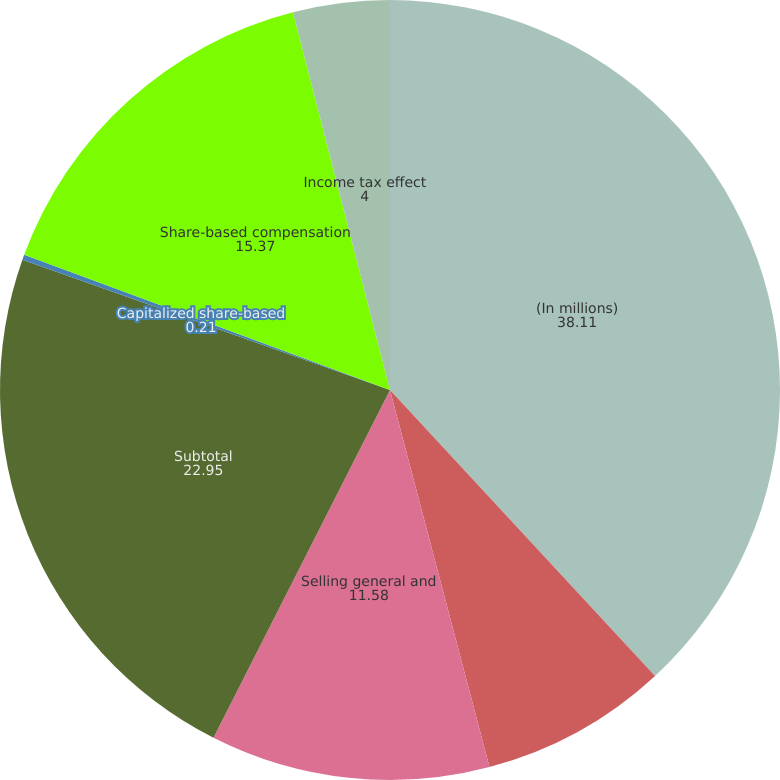<chart> <loc_0><loc_0><loc_500><loc_500><pie_chart><fcel>(In millions)<fcel>Research and development<fcel>Selling general and<fcel>Subtotal<fcel>Capitalized share-based<fcel>Share-based compensation<fcel>Income tax effect<nl><fcel>38.11%<fcel>7.79%<fcel>11.58%<fcel>22.95%<fcel>0.21%<fcel>15.37%<fcel>4.0%<nl></chart> 